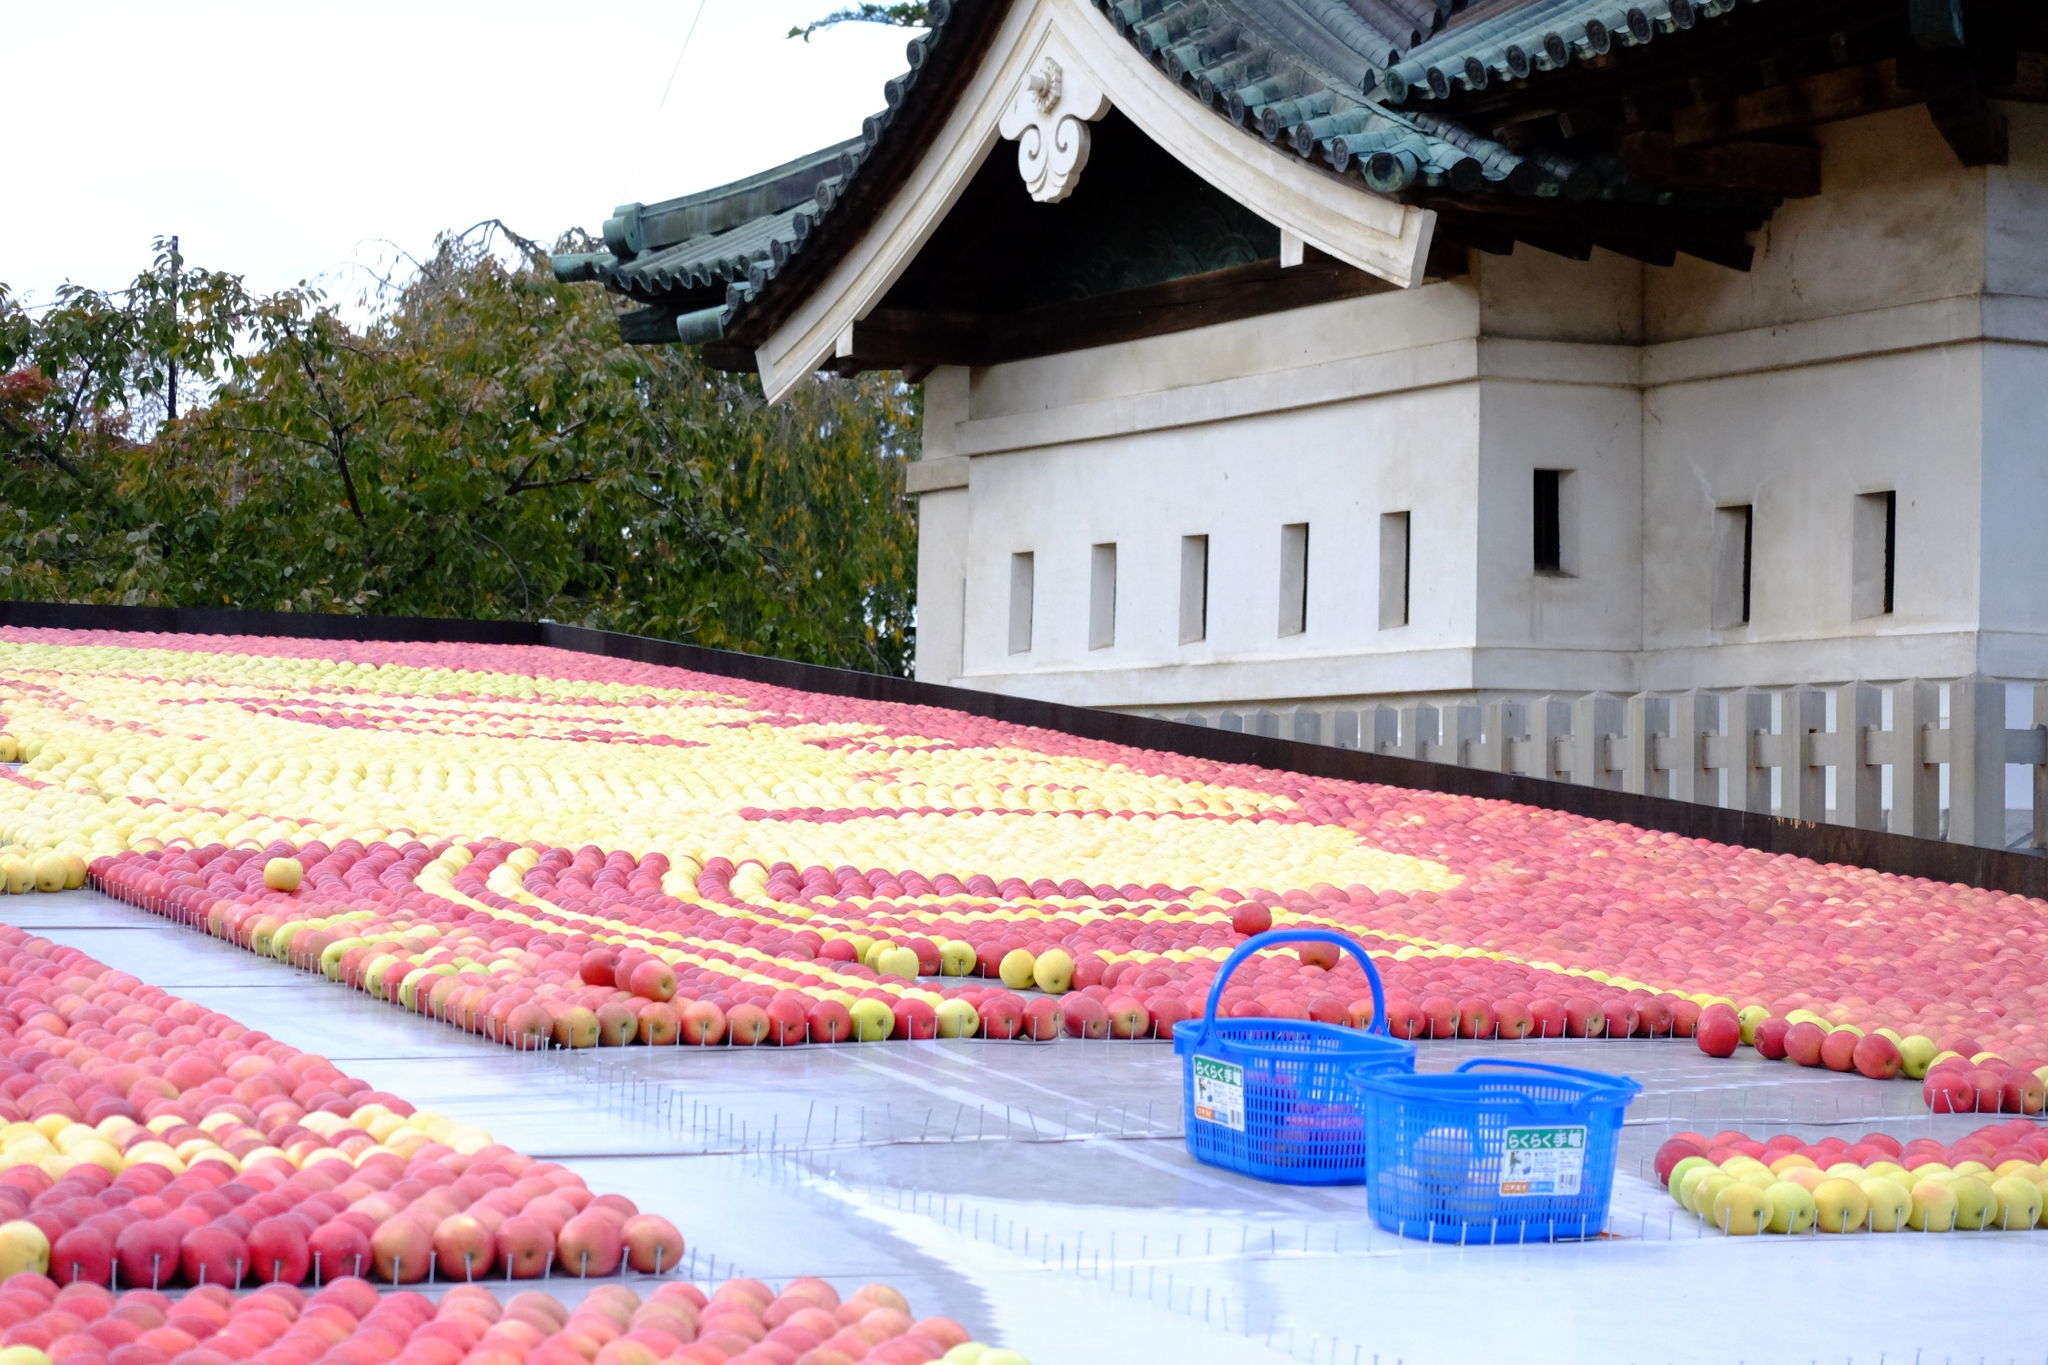Is there any significance to the location of this event in front of this particular temple? Yes, the placement in front of the temple is significant. In Japanese culture, temples are centers of community life and spiritual practice. By hosting the apple display here, organizers tie the event to the community's cultural and spiritual dimensions. It reflects respect and reverence for nature's bounty, seen as blessings, and showcases the fruits in a context that elevates them beyond mere agricultural products to symbols of prosperity and spiritual wellbeing. What role might the temple play during such events? The temple likely serves multiple roles during such events, including providing a space for rituals or ceremonies related to the harvest, offering blessings for future prosperity, and acting as a gathering place for the community. It may also help in promoting cultural continuity by integrating traditional practices with contemporary community activities, ensuring that cultural heritage is maintained and celebrated among all age groups. 